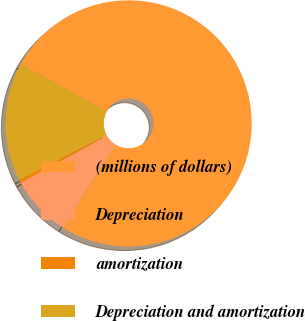<chart> <loc_0><loc_0><loc_500><loc_500><pie_chart><fcel>(millions of dollars)<fcel>Depreciation<fcel>amortization<fcel>Depreciation and amortization<nl><fcel>75.96%<fcel>8.01%<fcel>0.46%<fcel>15.56%<nl></chart> 